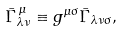<formula> <loc_0><loc_0><loc_500><loc_500>\bar { \Gamma } _ { \lambda \nu } ^ { \, \mu } \equiv g ^ { \mu \sigma } \bar { \Gamma } _ { \lambda \nu \sigma } ,</formula> 